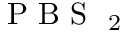<formula> <loc_0><loc_0><loc_500><loc_500>P B S _ { 2 }</formula> 